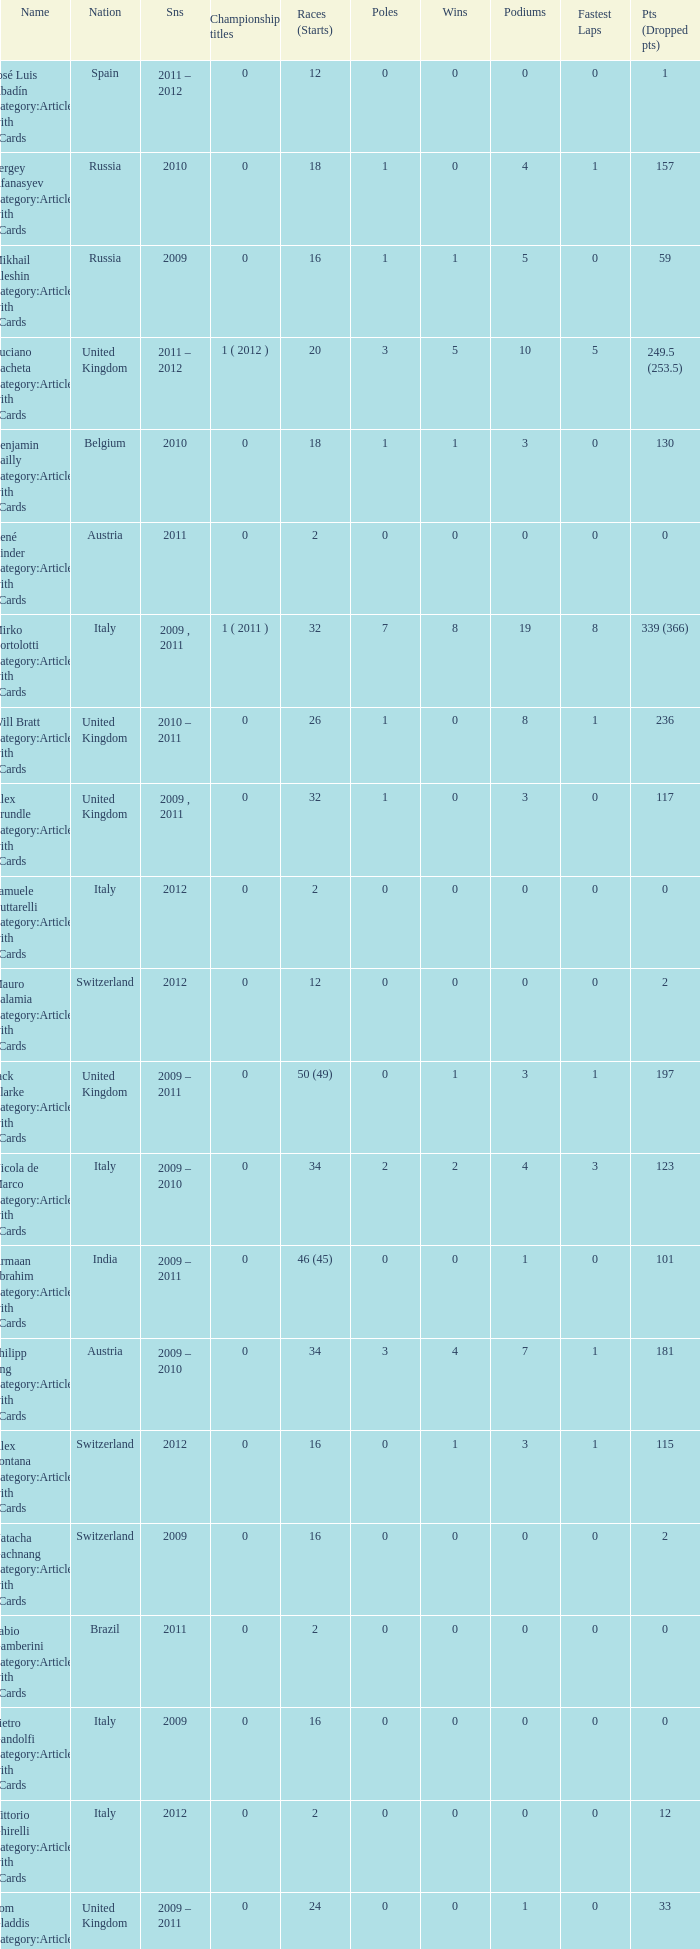When did they win 7 races? 2009.0. 